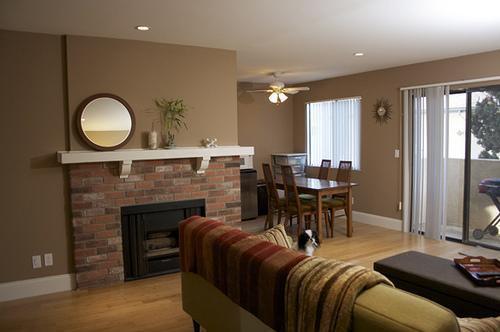How many chairs are in the photo?
Give a very brief answer. 1. 